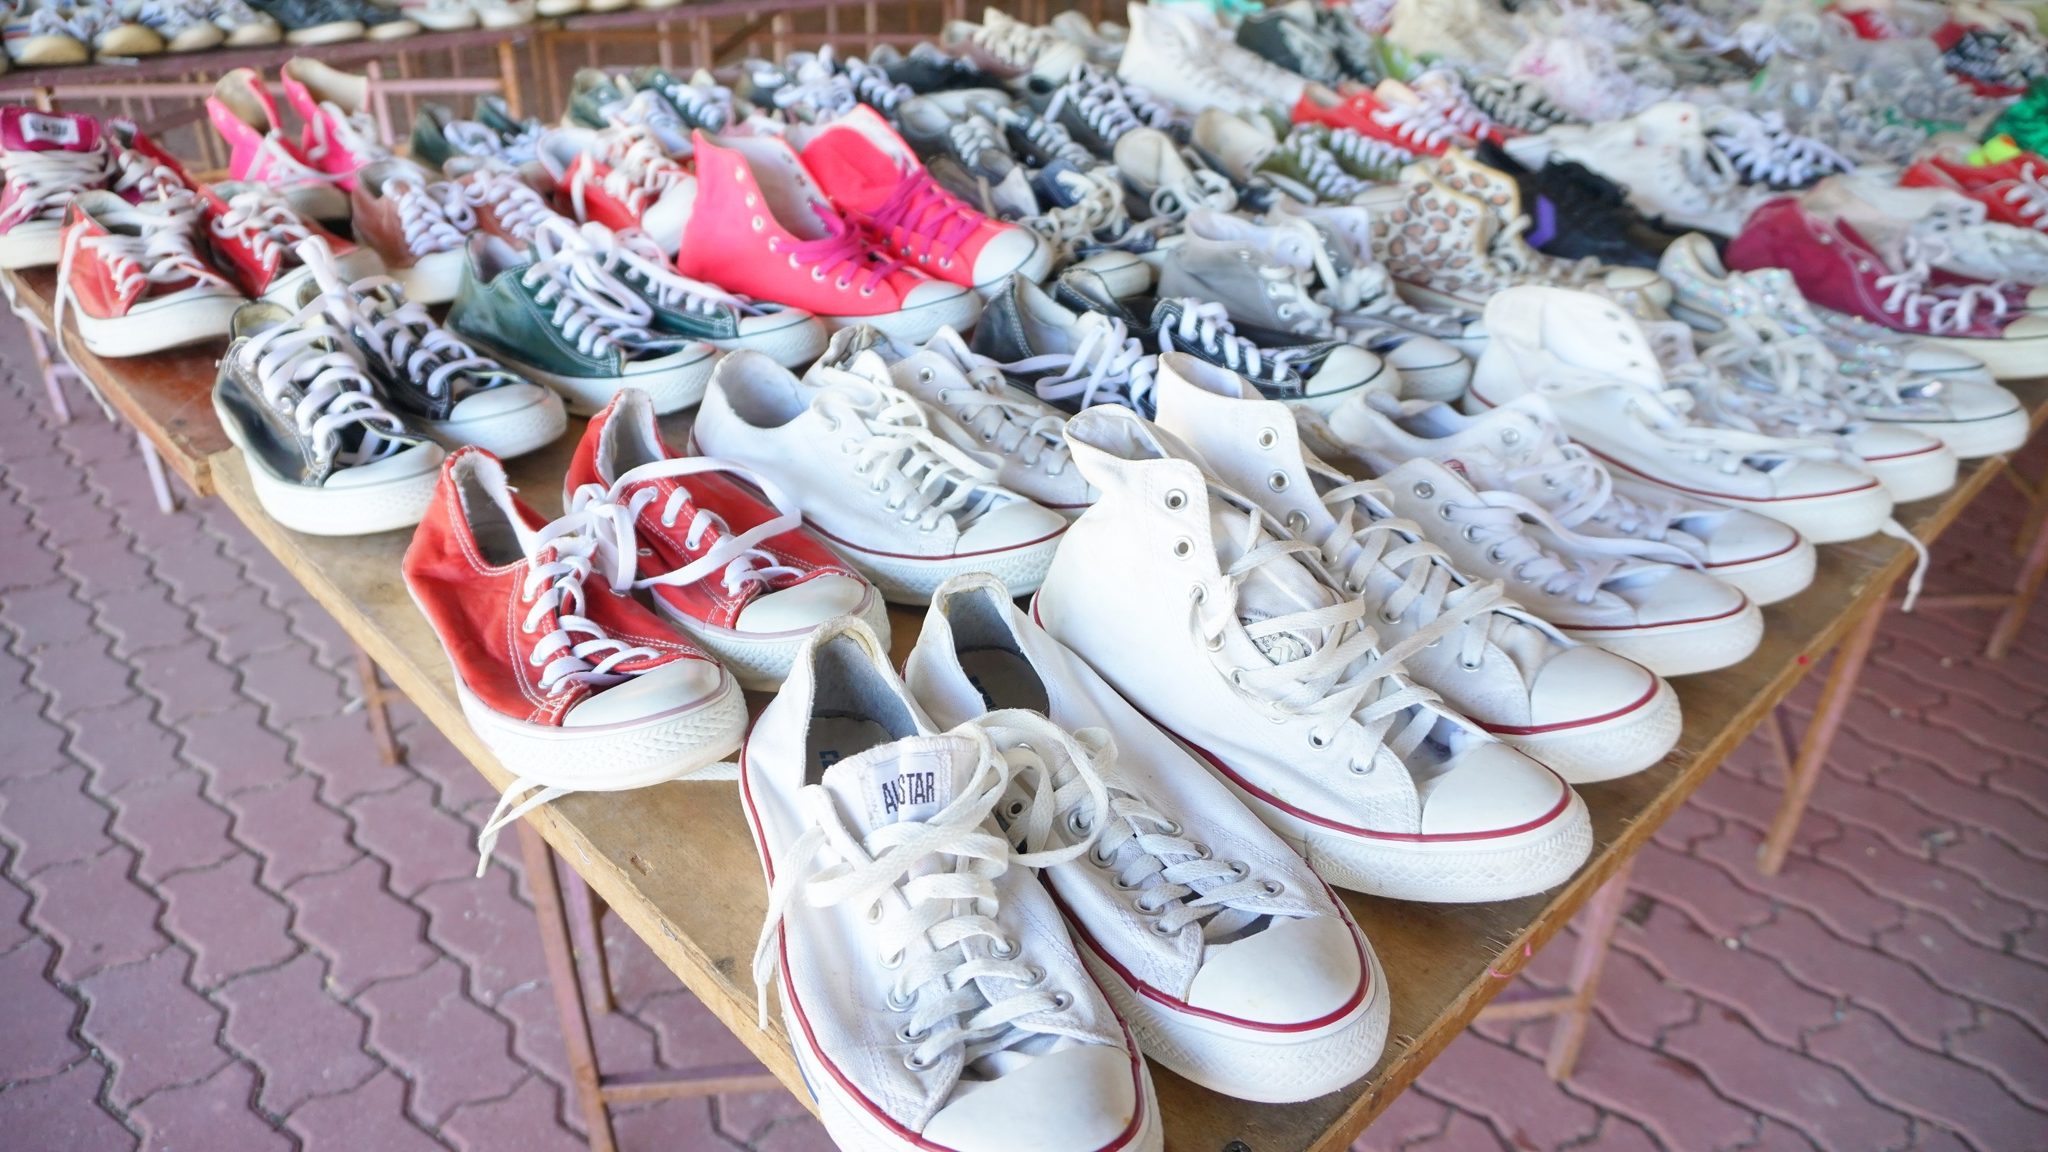Imagine a world where sneakers are the primary mode of transportation. How would that change society? In a world where sneakers are the primary mode of transportation, society would undergo remarkable transformations. Urban planning would prioritize extensive networks of pedestrian-friendly paths, significantly reducing cars, leading to a greener, quieter environment. Businesses would flourish around customizing and maintaining high-quality sneakers, and individuals would boast collections of sneakers designed for various terrains and distances. Public events like marathons or walkathons would be major social gatherings, fostering community spirit. Economically, healthcare costs might lower with increased physical activity, though cobbler professions might see a resurgence. Sneakers as the main transit mode could change fashion trends, cultural practices, and even social status, with innovative designs becoming symbols of mobility and freedom. What kind of cultural shifts could arise from our footwear becoming our transport? Culturally, we might see a shift in how status and style are perceived. Footwear brands could become more influential, with cutting-edge technology and unique designs becoming status symbols. Festivals could emerge celebrating the art and science of sneaker design, merging fashion with functionality. Dance and movement-focused activities might become more integrated into daily life, promoting healthier lifestyles. Stories, legends, and even folklore could evolve, centering around legendary sneakers of the past and heroes who wore them. The collective consciousness might turn towards more sustainable practices as people realize the wear and tear on their primary 'transport' method, pushing innovations in durable, eco-friendly materials. 